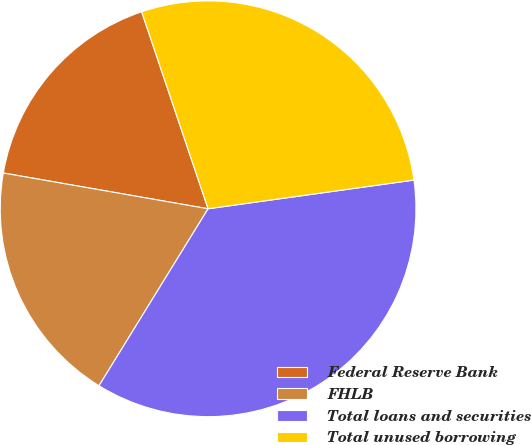Convert chart. <chart><loc_0><loc_0><loc_500><loc_500><pie_chart><fcel>Federal Reserve Bank<fcel>FHLB<fcel>Total loans and securities<fcel>Total unused borrowing<nl><fcel>17.07%<fcel>18.96%<fcel>35.99%<fcel>27.97%<nl></chart> 